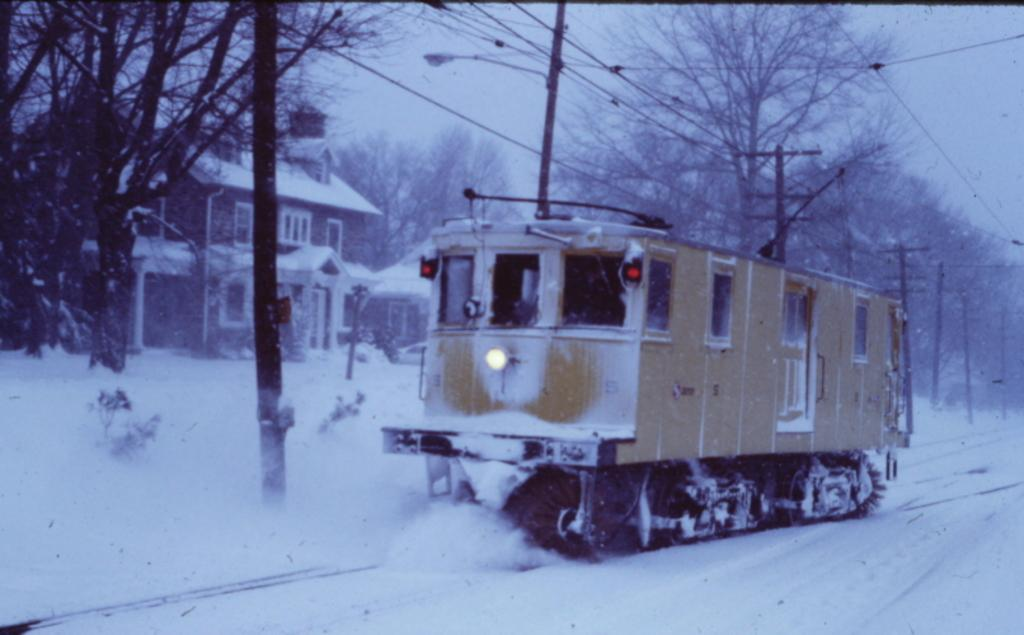What type of vehicle is in the image? There is a tram in the image. Where is the tram located? The tram is on a tramway track. What is the weather like in the image? There is snow in the image. What type of building can be seen in the image? There is a house in the image. What structures are present alongside the tramway track? There are poles in the image. What connects the poles in the image? There are cables in the image. What type of vegetation is visible in the image? There are trees in the image. What can be seen in the background of the image? The sky is visible in the background of the image. What type of farm animals can be seen grazing in the image? There is no farm or farm animals present in the image. What type of carriage is being pulled by horses in the image? There is no carriage or horses present in the image. 